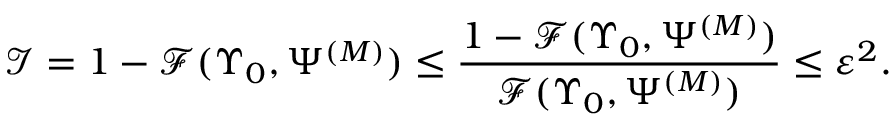<formula> <loc_0><loc_0><loc_500><loc_500>\mathcal { I } = 1 - \mathcal { F } ( \Upsilon _ { 0 } , \Psi ^ { ( M ) } ) \leq \frac { 1 - \mathcal { F } ( \Upsilon _ { 0 } , \Psi ^ { ( M ) } ) } { \mathcal { F } ( \Upsilon _ { 0 } , \Psi ^ { ( M ) } ) } \leq \varepsilon ^ { 2 } .</formula> 